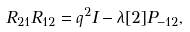<formula> <loc_0><loc_0><loc_500><loc_500>R _ { 2 1 } R _ { 1 2 } = q ^ { 2 } I - \lambda [ 2 ] P _ { - 1 2 } ,</formula> 